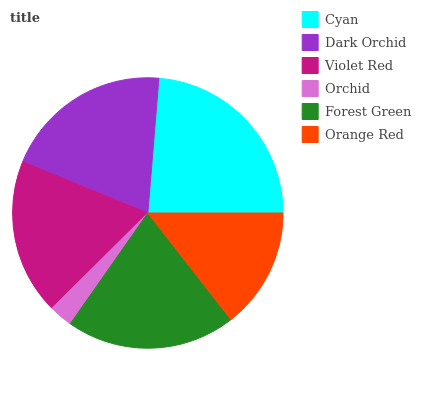Is Orchid the minimum?
Answer yes or no. Yes. Is Cyan the maximum?
Answer yes or no. Yes. Is Dark Orchid the minimum?
Answer yes or no. No. Is Dark Orchid the maximum?
Answer yes or no. No. Is Cyan greater than Dark Orchid?
Answer yes or no. Yes. Is Dark Orchid less than Cyan?
Answer yes or no. Yes. Is Dark Orchid greater than Cyan?
Answer yes or no. No. Is Cyan less than Dark Orchid?
Answer yes or no. No. Is Dark Orchid the high median?
Answer yes or no. Yes. Is Violet Red the low median?
Answer yes or no. Yes. Is Forest Green the high median?
Answer yes or no. No. Is Dark Orchid the low median?
Answer yes or no. No. 